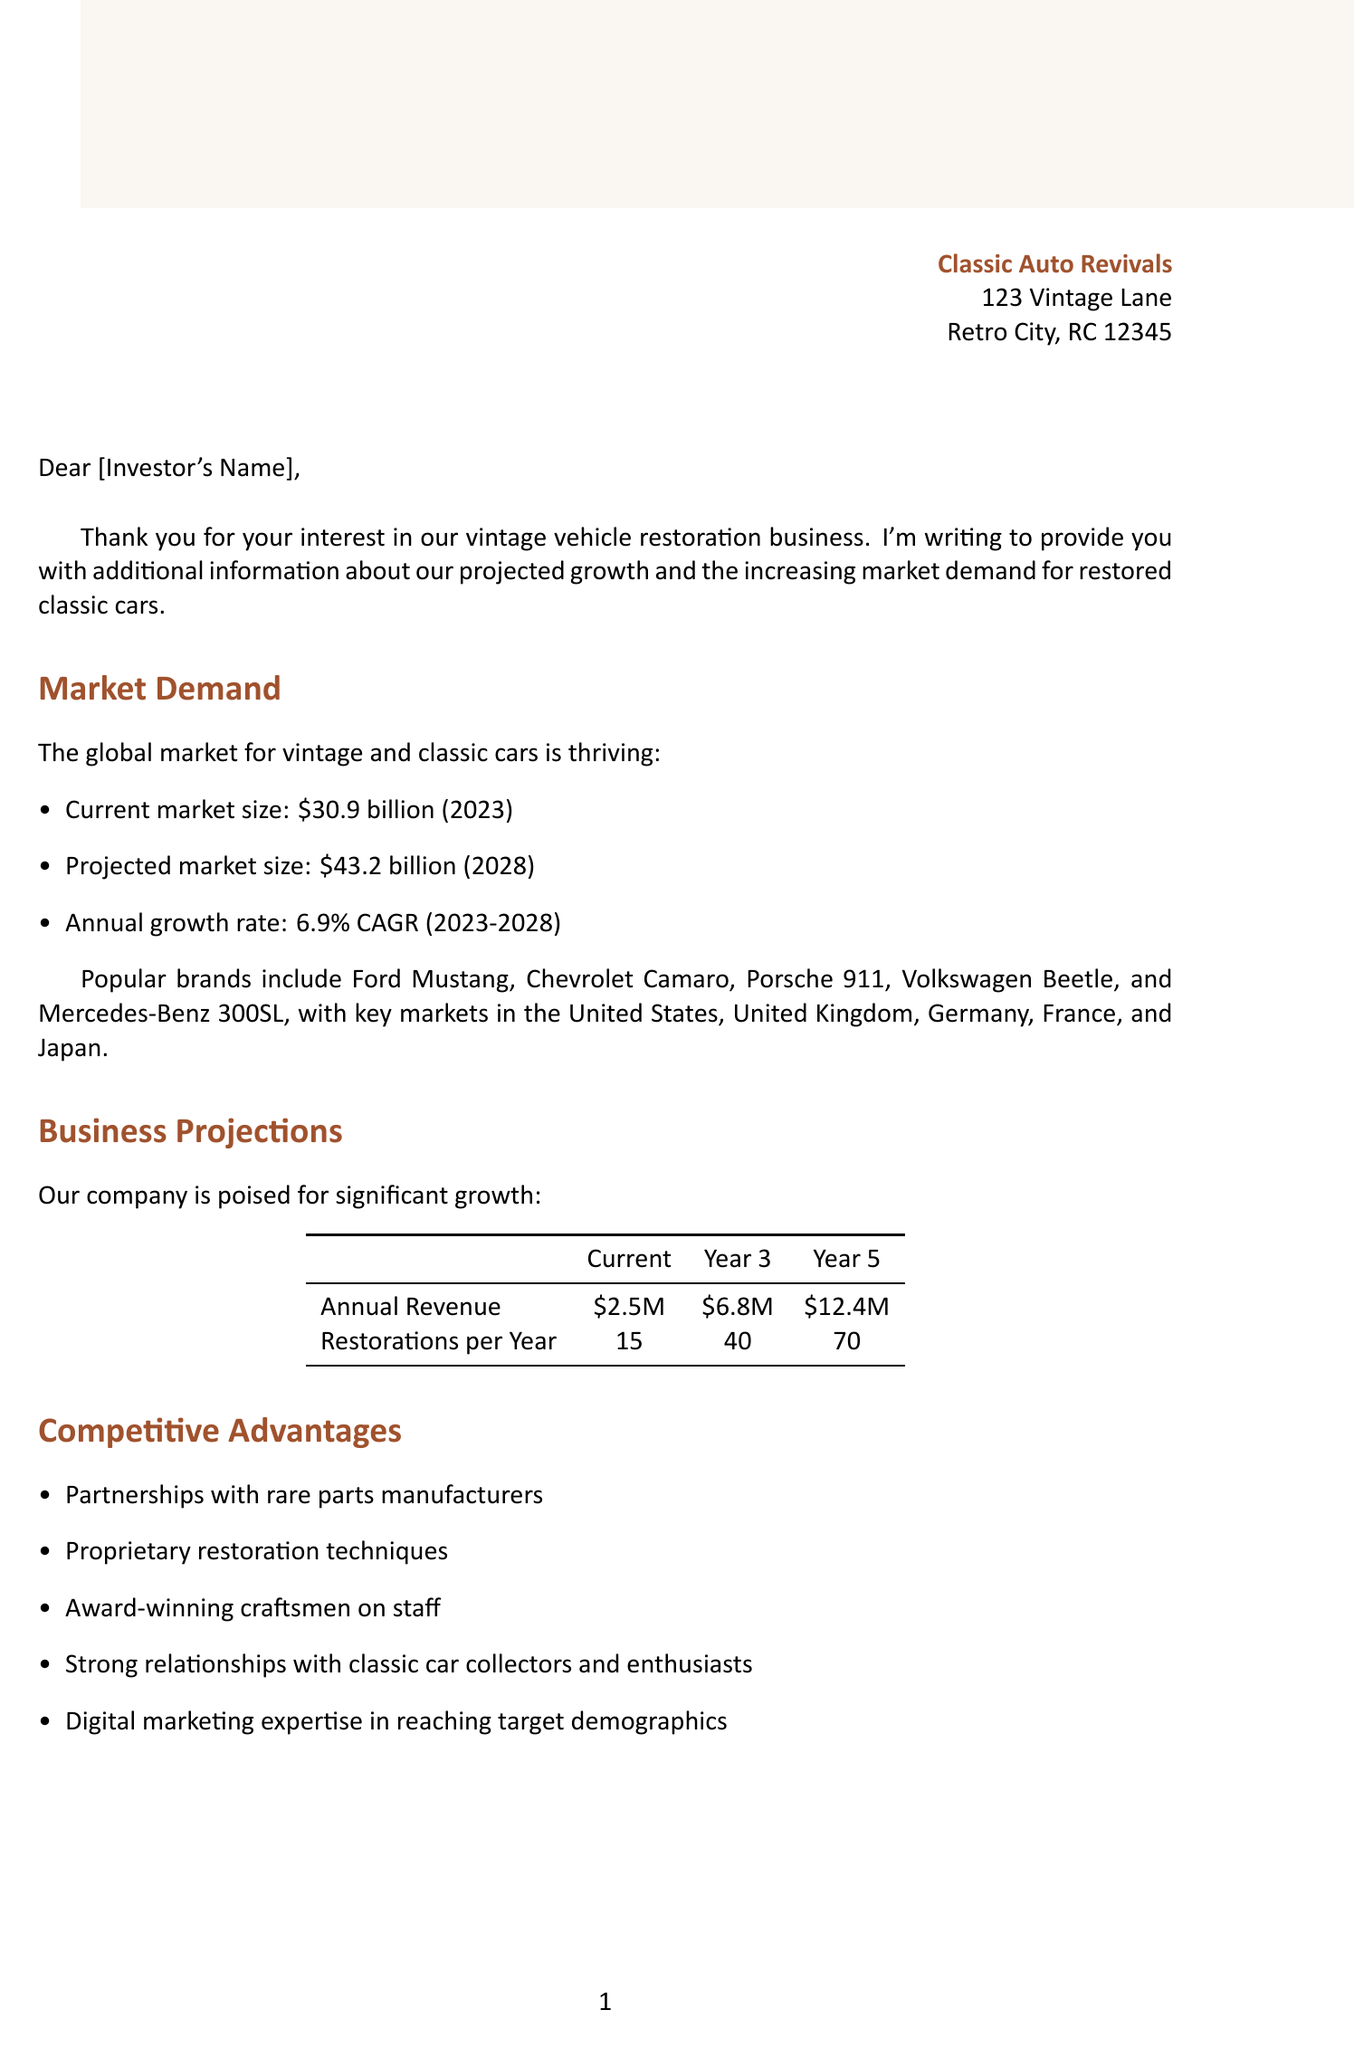What is the current market size for vintage cars? The document states the current market size is $30.9 billion in 2023.
Answer: $30.9 billion What is the projected market size by 2028? The document mentions that the projected market size is $43.2 billion by 2028.
Answer: $43.2 billion What is the annual revenue in Year 5? According to the document, the projected annual revenue in Year 5 is $12.4 million.
Answer: $12.4 million How many restorations are projected for Year 3? The document indicates that there are projected to be 40 restorations per year in Year 3.
Answer: 40 What are the key markets mentioned for vintage vehicle sales? The document lists the key markets as the United States, United Kingdom, Germany, France, and Japan.
Answer: United States, United Kingdom, Germany, France, Japan What percentage is the projected ROI? The projected ROI mentioned in the document is 25% annually over 5 years.
Answer: 25% Who provided a testimonial praising the quality of restorations? The document cites Jay Leno and Jerry Seinfeld as individuals providing testimonials.
Answer: Jay Leno, Jerry Seinfeld What is the total investment sought? The document states that the total investment sought is $3.5 million.
Answer: $3.5 million What is the exit strategy mentioned? The exit strategy as described in the document is a potential IPO or acquisition by a major automotive group within 7-10 years.
Answer: Potential IPO or acquisition by major automotive group within 7-10 years 